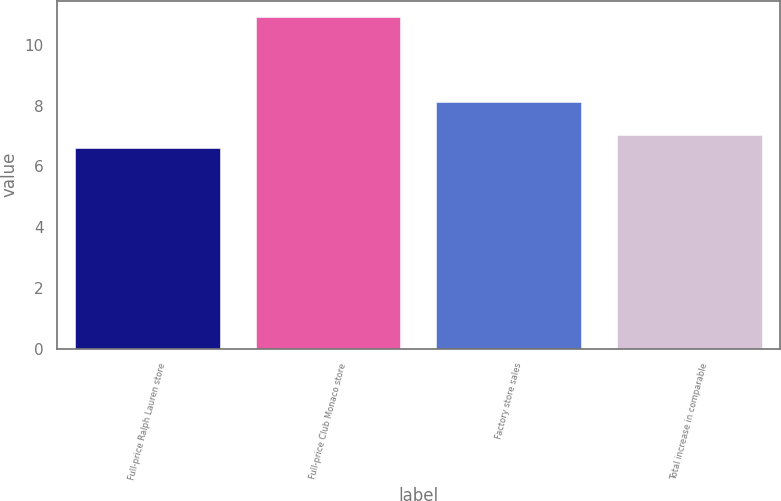Convert chart. <chart><loc_0><loc_0><loc_500><loc_500><bar_chart><fcel>Full-price Ralph Lauren store<fcel>Full-price Club Monaco store<fcel>Factory store sales<fcel>Total increase in comparable<nl><fcel>6.6<fcel>10.9<fcel>8.1<fcel>7.03<nl></chart> 